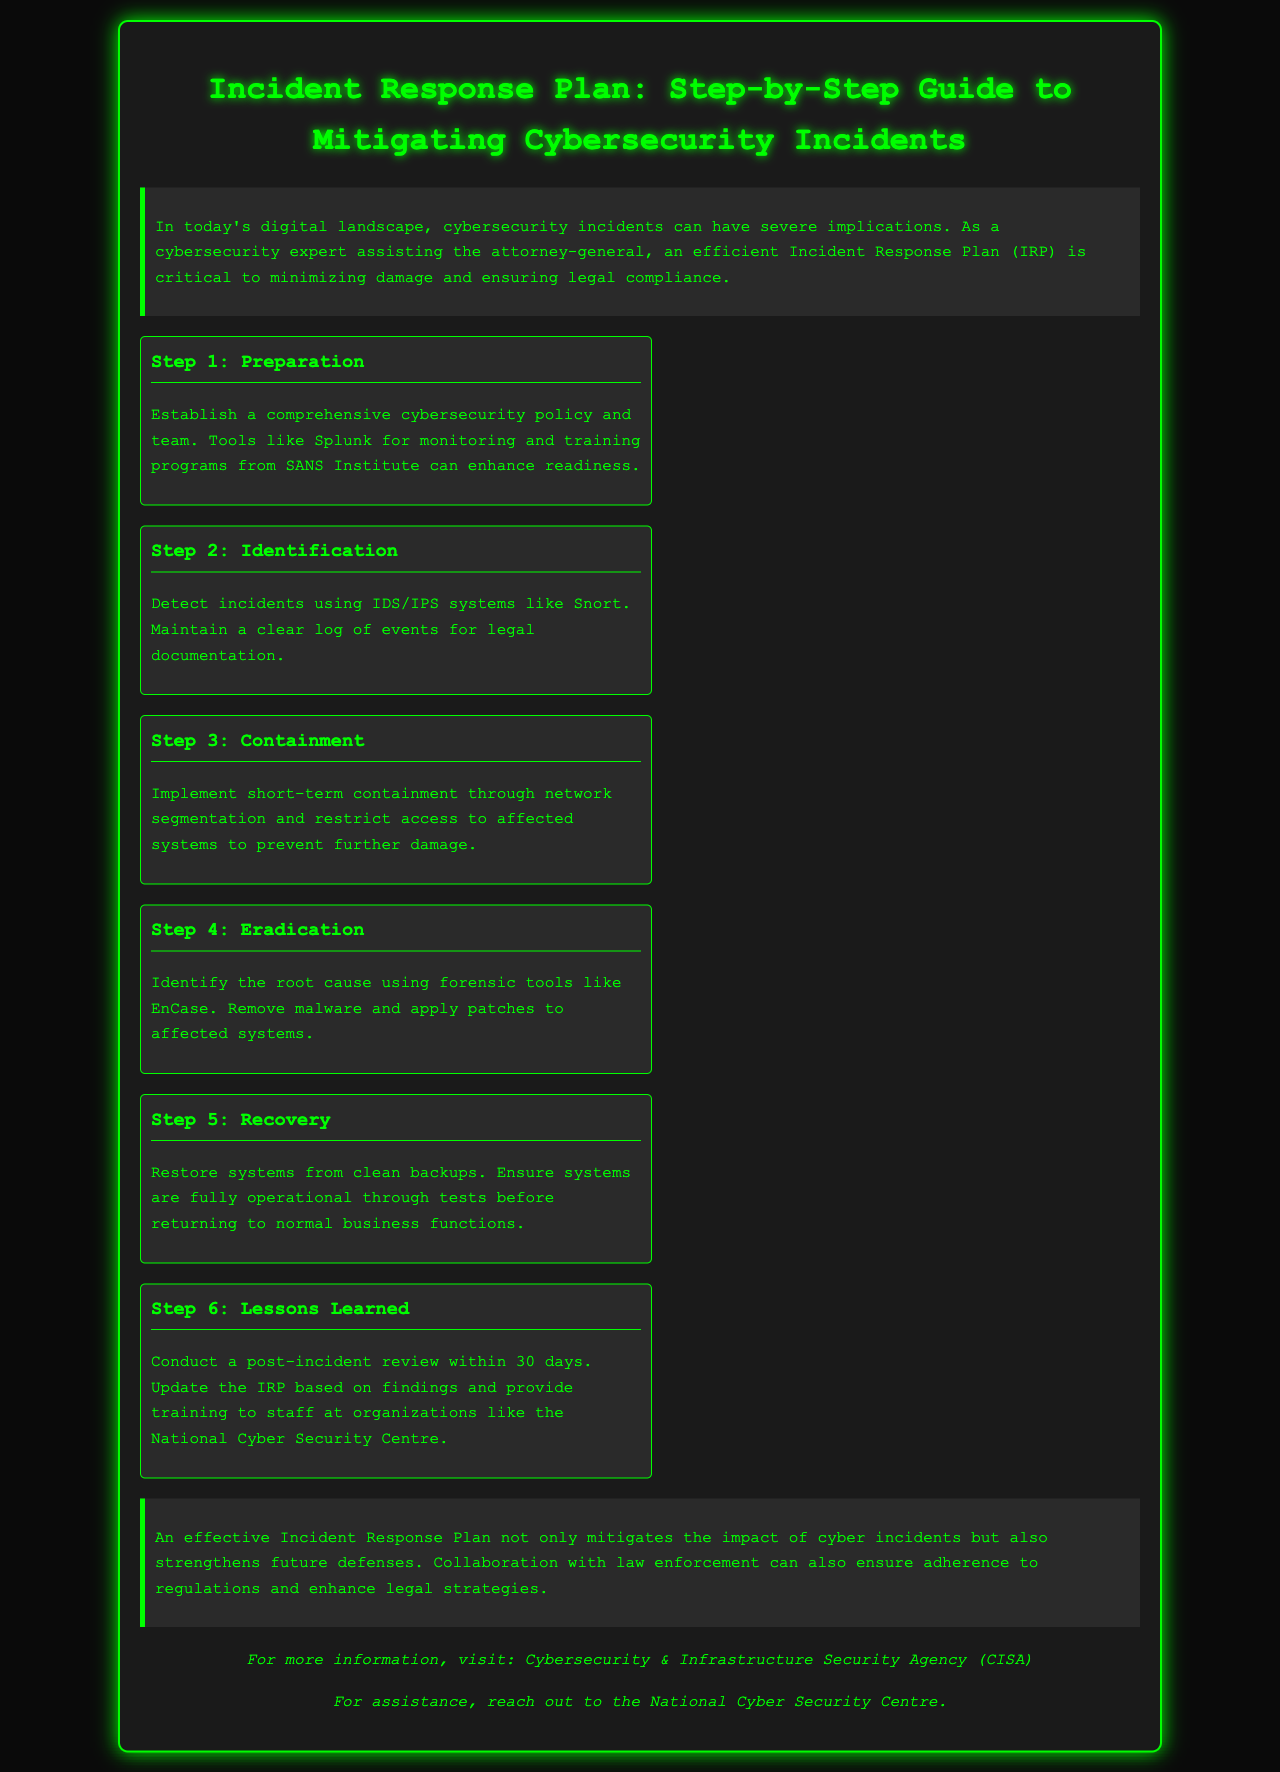What is the title of the document? The title is prominently displayed at the top of the document, stating the main subject of the content.
Answer: Incident Response Plan: Step-by-Step Guide to Mitigating Cybersecurity Incidents What is the first step in the Incident Response Plan? The steps of the Incident Response Plan are clearly listed and the first step is labeled as such.
Answer: Preparation How many steps are listed in the Incident Response Plan? The document outlines a specific number of steps that are necessary for an effective Incident Response Plan.
Answer: Six What tool is mentioned for monitoring in the Preparation step? The Preparation step includes a specific tool that enhances cybersecurity readiness, which is noted in the text.
Answer: Splunk What should be done within 30 days after an incident? The document states a specific timeframe for conducting a review post-incident, which indicates a necessary action.
Answer: Conduct a post-incident review What organization is suggested for training staff? The steps include a mention of a specific organization that provides training relevant to cybersecurity.
Answer: National Cyber Security Centre What is emphasized as a benefit of an effective Incident Response Plan? The conclusion of the document highlights the advantages gained from having a robust Incident Response Plan in place.
Answer: Strengthens future defenses What is the main goal of the Containment step? The Containment step describes its primary objective related to system and network security during an incident.
Answer: Prevent further damage Which agency is recommended for more information in the resources section? The document includes a resources section that suggests an agency for additional details regarding cybersecurity.
Answer: Cybersecurity & Infrastructure Security Agency (CISA) 